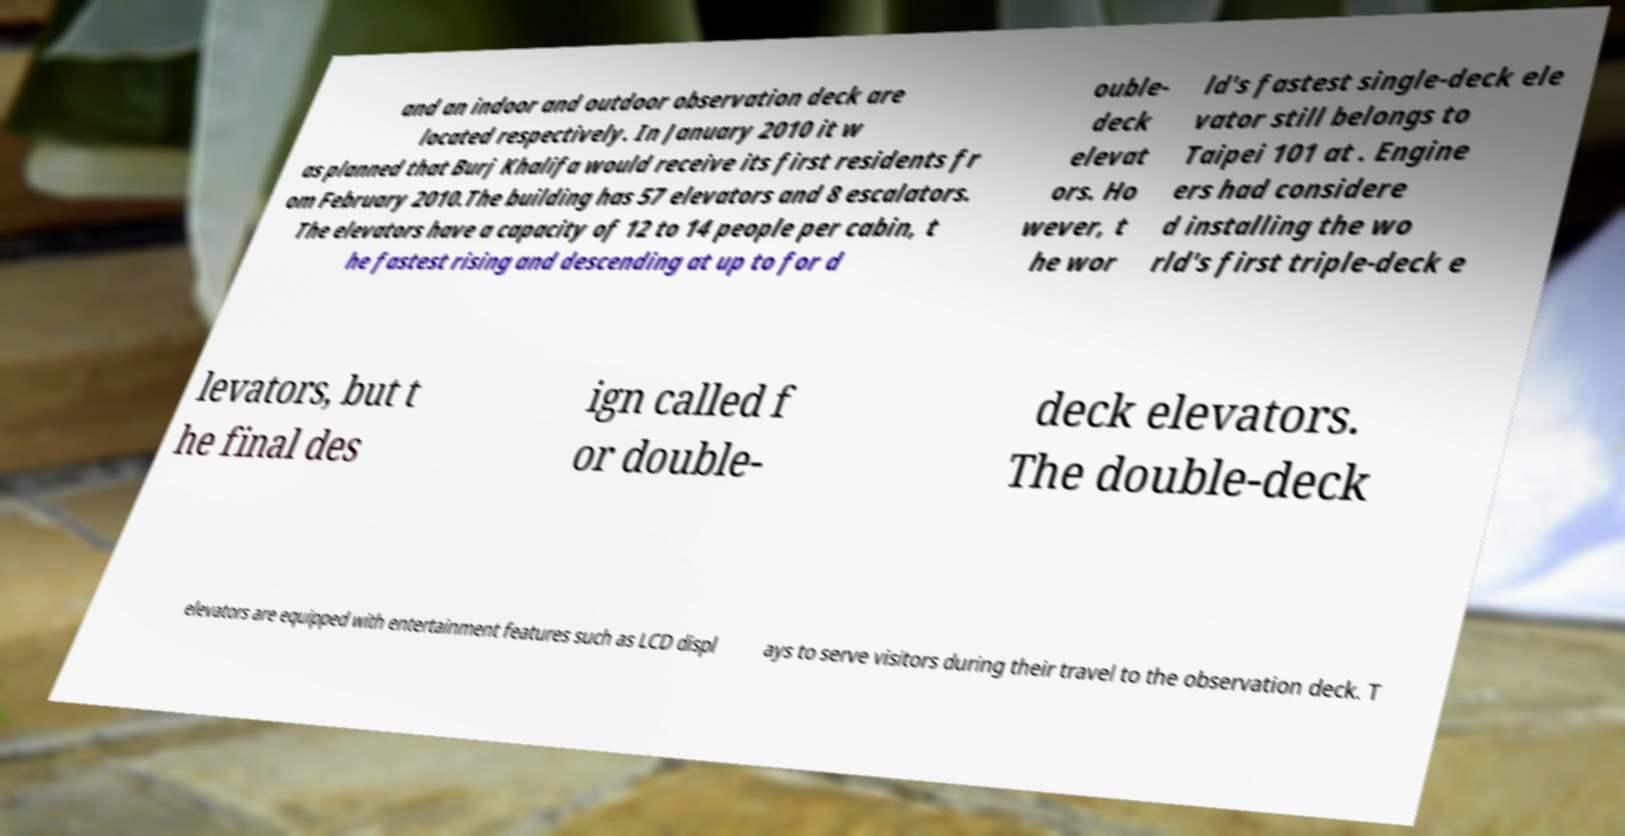Can you read and provide the text displayed in the image?This photo seems to have some interesting text. Can you extract and type it out for me? and an indoor and outdoor observation deck are located respectively. In January 2010 it w as planned that Burj Khalifa would receive its first residents fr om February 2010.The building has 57 elevators and 8 escalators. The elevators have a capacity of 12 to 14 people per cabin, t he fastest rising and descending at up to for d ouble- deck elevat ors. Ho wever, t he wor ld's fastest single-deck ele vator still belongs to Taipei 101 at . Engine ers had considere d installing the wo rld's first triple-deck e levators, but t he final des ign called f or double- deck elevators. The double-deck elevators are equipped with entertainment features such as LCD displ ays to serve visitors during their travel to the observation deck. T 